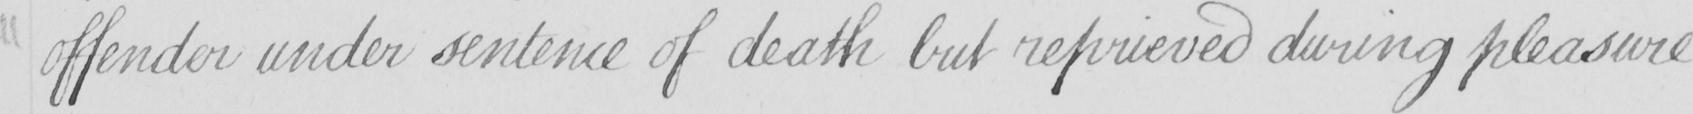Can you tell me what this handwritten text says? offender under sentence of death but reprieved during pleasure 